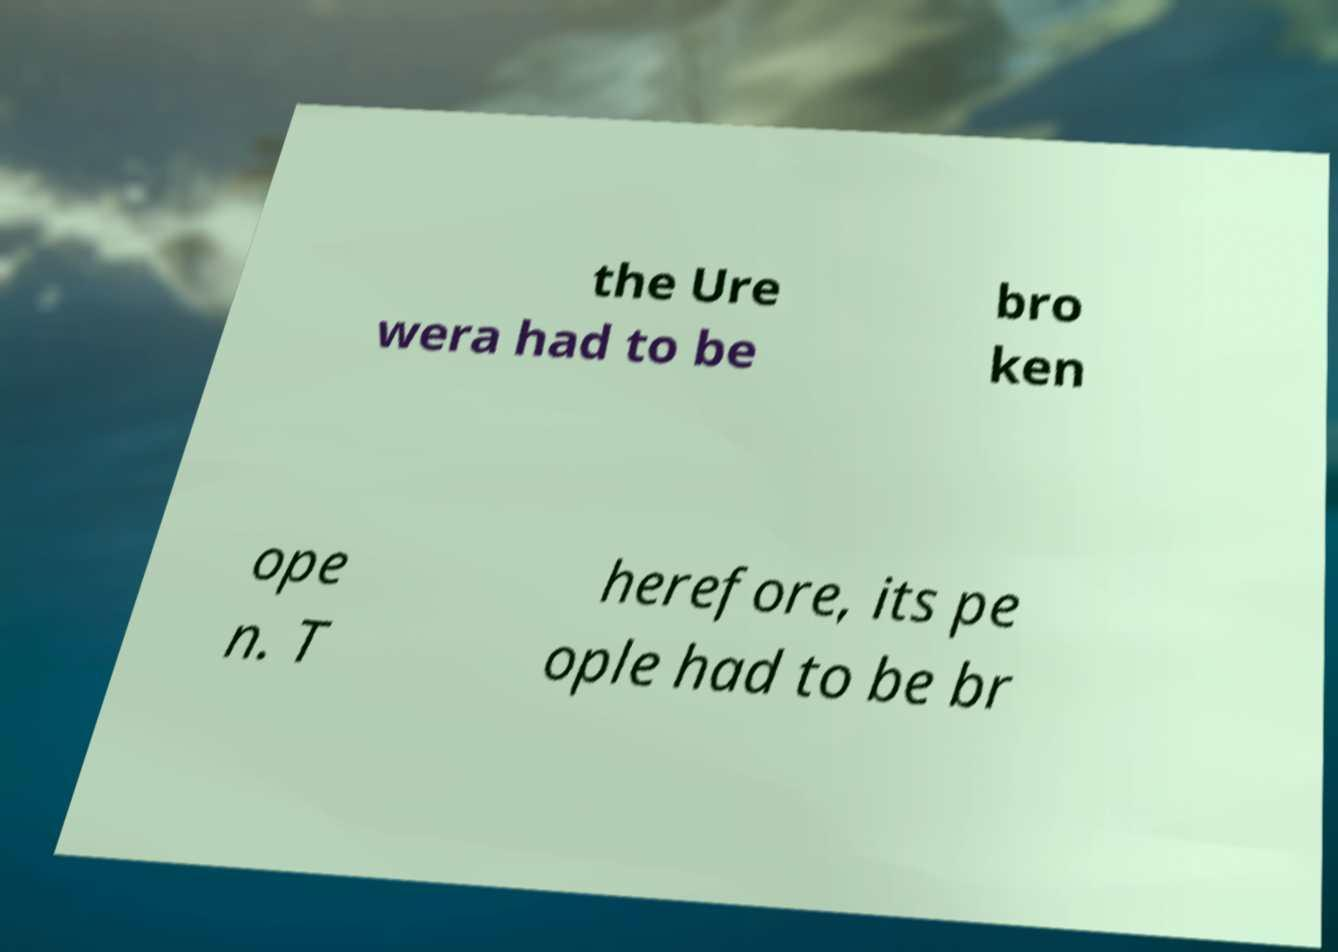Could you assist in decoding the text presented in this image and type it out clearly? the Ure wera had to be bro ken ope n. T herefore, its pe ople had to be br 